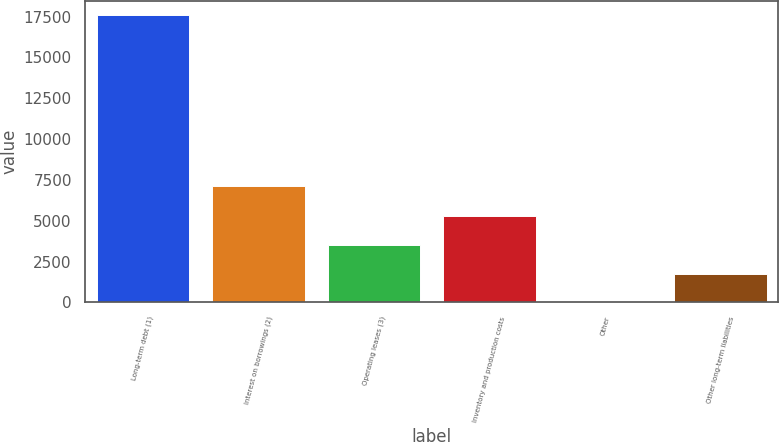Convert chart to OTSL. <chart><loc_0><loc_0><loc_500><loc_500><bar_chart><fcel>Long-term debt (1)<fcel>Interest on borrowings (2)<fcel>Operating leases (3)<fcel>Inventory and production costs<fcel>Other<fcel>Other long-term liabilities<nl><fcel>17582<fcel>7122<fcel>3525.2<fcel>5282.3<fcel>11<fcel>1768.1<nl></chart> 